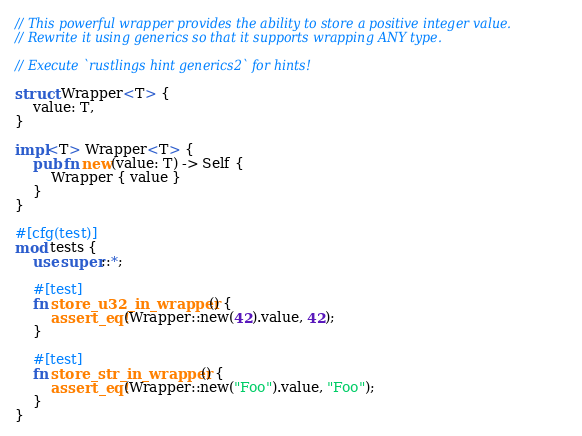<code> <loc_0><loc_0><loc_500><loc_500><_Rust_>// This powerful wrapper provides the ability to store a positive integer value.
// Rewrite it using generics so that it supports wrapping ANY type.

// Execute `rustlings hint generics2` for hints!

struct Wrapper<T> {
    value: T, 
}

impl<T> Wrapper<T> {
    pub fn new(value: T) -> Self {
        Wrapper { value }
    }
}

#[cfg(test)]
mod tests {
    use super::*;

    #[test]
    fn store_u32_in_wrapper() {
        assert_eq!(Wrapper::new(42).value, 42);
    }

    #[test]
    fn store_str_in_wrapper() {
        assert_eq!(Wrapper::new("Foo").value, "Foo");
    }
}
</code> 